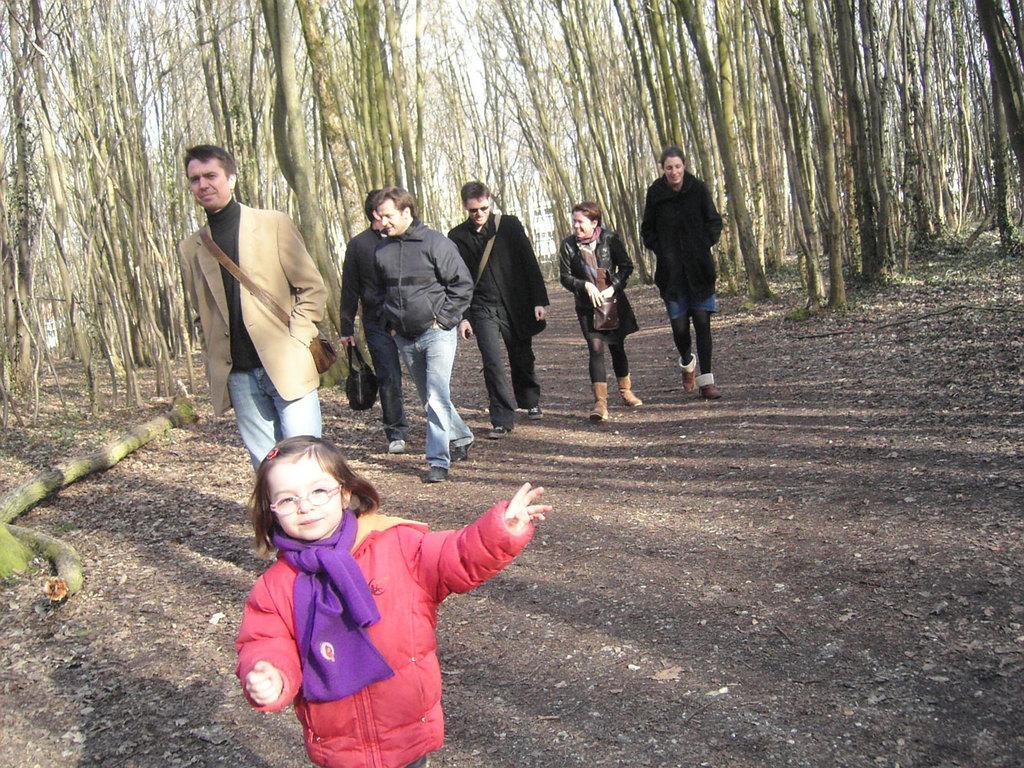How would you summarize this image in a sentence or two? In this picture we can see a child and a few people walking on the path. We can see a person holding a bag in his hand. There are a few tree trunks in the background. 